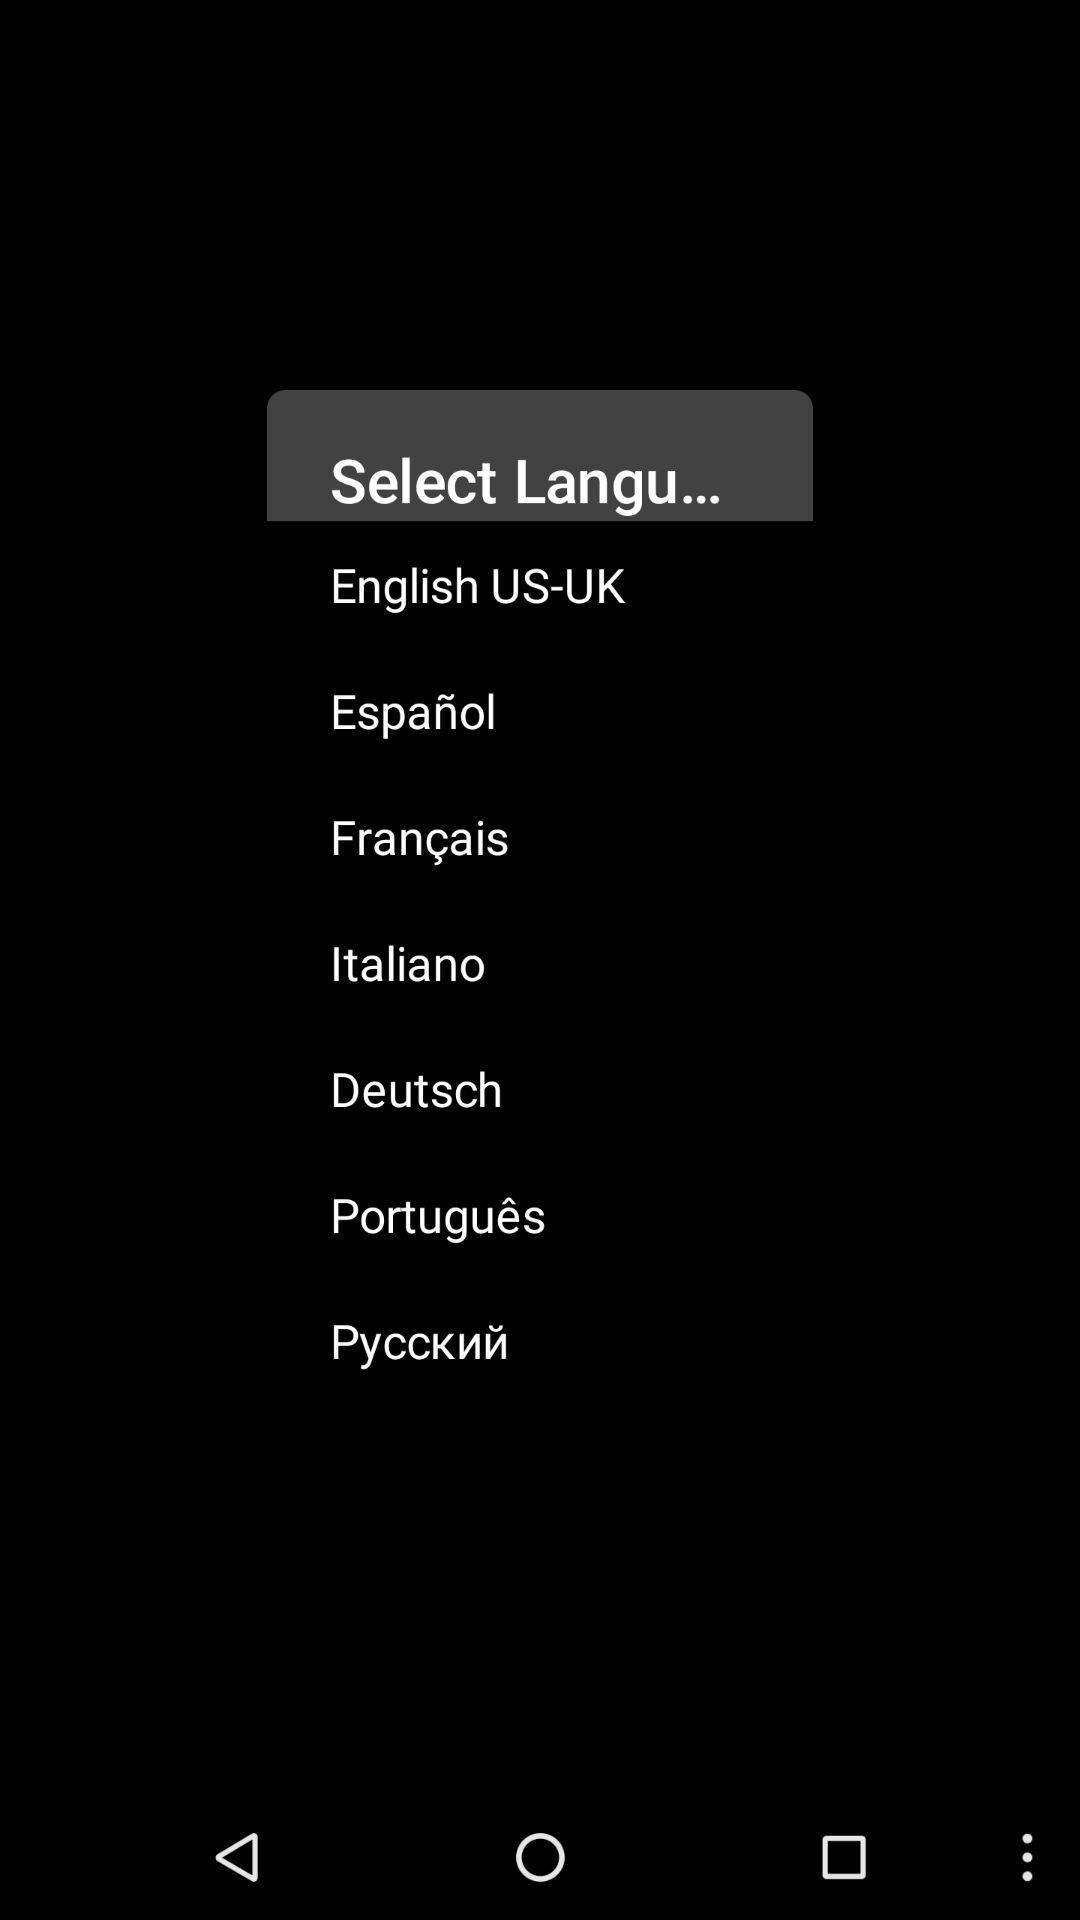How many languages are available for selection?
Answer the question using a single word or phrase. 7 